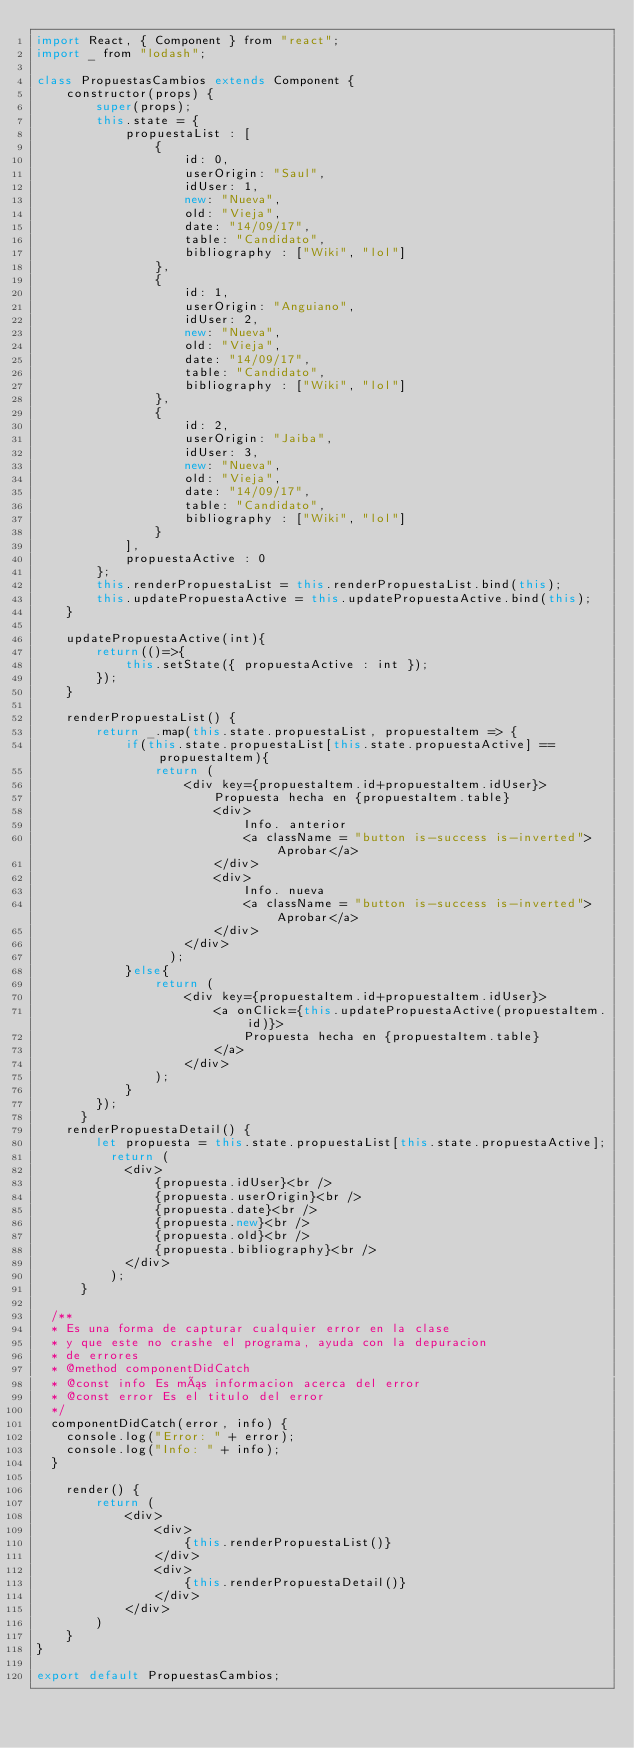Convert code to text. <code><loc_0><loc_0><loc_500><loc_500><_JavaScript_>import React, { Component } from "react";
import _ from "lodash";

class PropuestasCambios extends Component {
    constructor(props) {
        super(props);
        this.state = {
            propuestaList : [
                {
                    id: 0, 
                    userOrigin: "Saul",
                    idUser: 1,
                    new: "Nueva",
                    old: "Vieja",
                    date: "14/09/17",
                    table: "Candidato",
                    bibliography : ["Wiki", "lol"]
                },
                {
                    id: 1, 
                    userOrigin: "Anguiano",
                    idUser: 2,
                    new: "Nueva",
                    old: "Vieja",
                    date: "14/09/17",
                    table: "Candidato",
                    bibliography : ["Wiki", "lol"]
                },
                {
                    id: 2, 
                    userOrigin: "Jaiba",
                    idUser: 3,
                    new: "Nueva",
                    old: "Vieja",
                    date: "14/09/17",
                    table: "Candidato",
                    bibliography : ["Wiki", "lol"]
                }
            ],
            propuestaActive : 0
        };
        this.renderPropuestaList = this.renderPropuestaList.bind(this);
        this.updatePropuestaActive = this.updatePropuestaActive.bind(this);
    }

    updatePropuestaActive(int){
        return(()=>{
            this.setState({ propuestaActive : int });
        });
    }

    renderPropuestaList() {
        return _.map(this.state.propuestaList, propuestaItem => {
            if(this.state.propuestaList[this.state.propuestaActive] == propuestaItem){
                return (
                    <div key={propuestaItem.id+propuestaItem.idUser}>
                        Propuesta hecha en {propuestaItem.table}
                        <div>
                            Info. anterior
                            <a className = "button is-success is-inverted">Aprobar</a>
                        </div>
                        <div>
                            Info. nueva
                            <a className = "button is-success is-inverted">Aprobar</a>
                        </div>
                    </div>
                  );
            }else{
                return (
                    <div key={propuestaItem.id+propuestaItem.idUser}>
                        <a onClick={this.updatePropuestaActive(propuestaItem.id)}>
                            Propuesta hecha en {propuestaItem.table}
                        </a>
                    </div>
                );
            }
        });
      }
    renderPropuestaDetail() {
        let propuesta = this.state.propuestaList[this.state.propuestaActive];
          return (
            <div>
                {propuesta.idUser}<br />
                {propuesta.userOrigin}<br />
                {propuesta.date}<br />
                {propuesta.new}<br />
                {propuesta.old}<br />
                {propuesta.bibliography}<br />
            </div>
          );
      }

  /**
  * Es una forma de capturar cualquier error en la clase 
  * y que este no crashe el programa, ayuda con la depuracion
  * de errores
  * @method componentDidCatch
  * @const info Es más informacion acerca del error
  * @const error Es el titulo del error
  */
  componentDidCatch(error, info) {
    console.log("Error: " + error);
    console.log("Info: " + info);
  }

    render() {
        return (
            <div>
                <div>
                    {this.renderPropuestaList()}
                </div>
                <div>
                    {this.renderPropuestaDetail()}
                </div>
            </div>
        )
    }
}

export default PropuestasCambios;</code> 